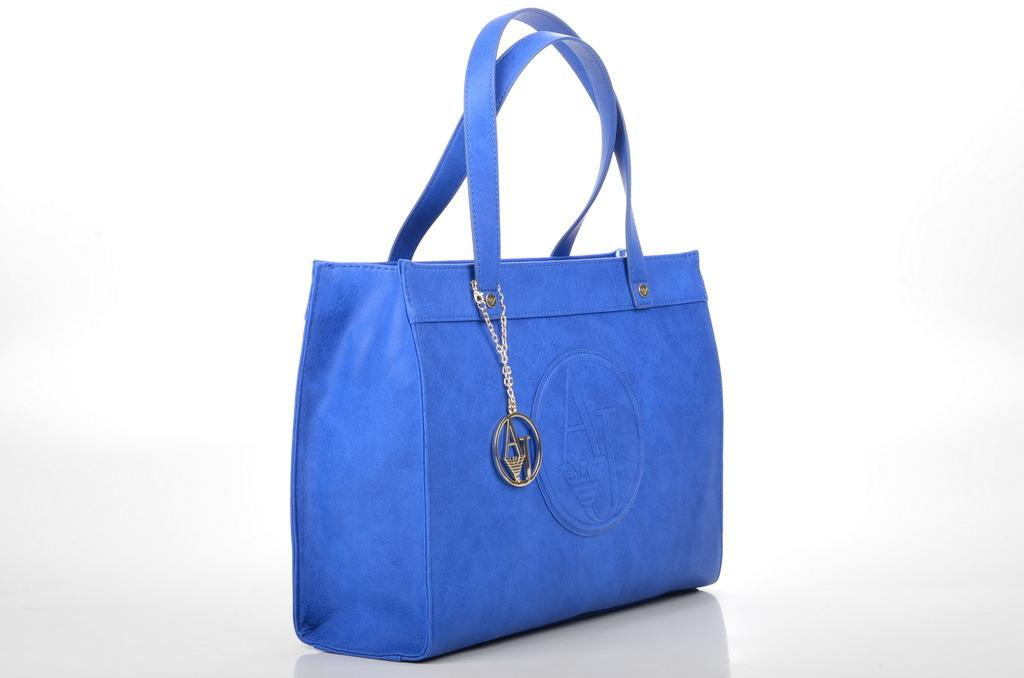What object is visible in the image that a person might use to carry items? There is a carry bag in the image that a person might use to carry items. Who does the carry bag belong to? The carry bag belongs to a woman. How is the carry bag designed to be carried? The carry bag has two straps. What can be found inside the carry bag? The carry bag contains a key chain-like object. What type of breakfast is the woman eating in the image? There is no indication of the woman eating breakfast in the image. 